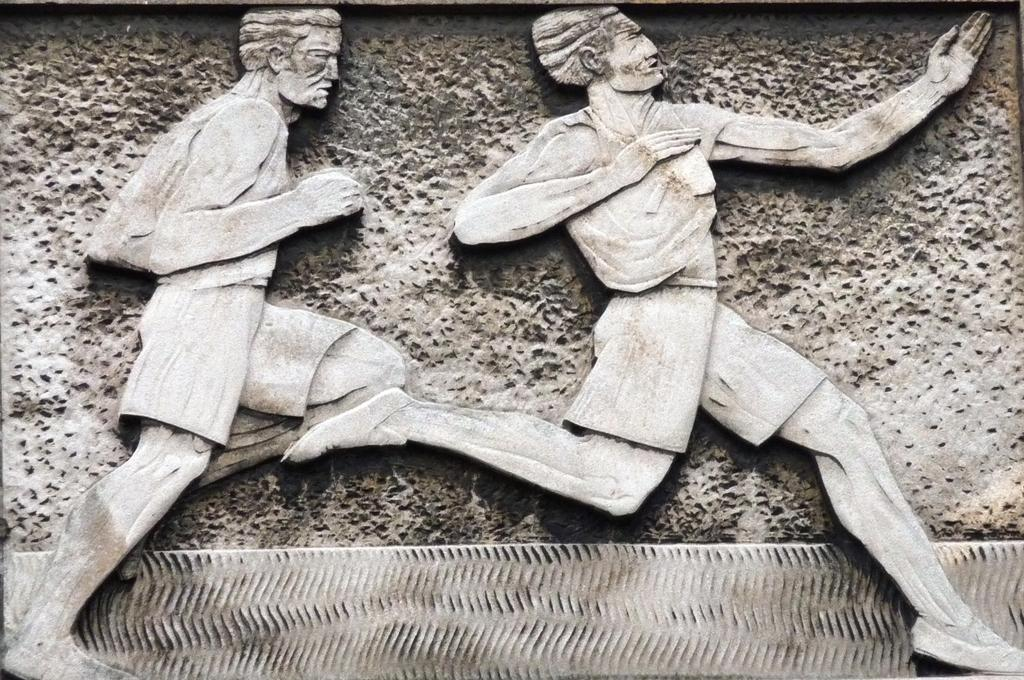What is present on the wall in the picture? There is a wall in the picture, and it has sculptures of two men. What are the sculptures depicting? The sculptures depict the men running. What type of reward can be seen in the hands of the men in the sculptures? There is no reward visible in the hands of the men in the sculptures; they are depicted as running. 